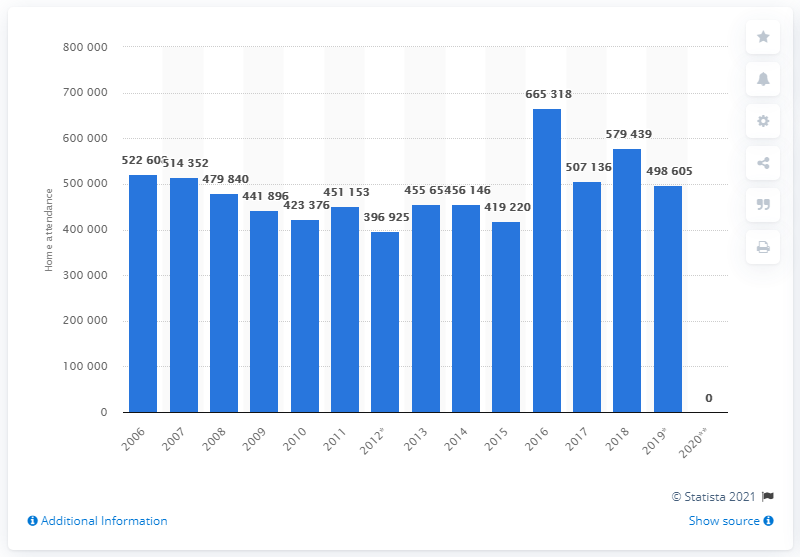Outline some significant characteristics in this image. In the year 2016, the St. Louis Rams football team relocated to Los Angeles. 